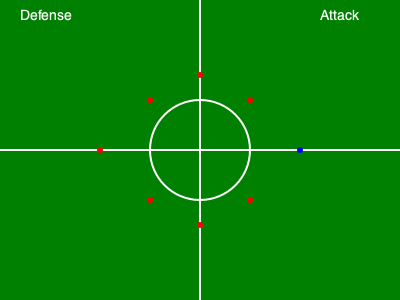Analyze the defensive formation shown in the rugby field schematic. What type of defensive strategy is being employed, and how might it be vulnerable to certain attacking plays? 1. Identification of the formation:
   The defensive formation shown is a "Drift Defense" or "Sliding Defense" strategy.

2. Key characteristics:
   a) The defenders (red dots) are arranged in a curved line, with players spread wider as they move away from the ruck/maul area.
   b) There's a concentration of defenders near the center of the field, with fewer players towards the touchlines.

3. Strengths of this formation:
   a) Effective at covering a wide area of the field.
   b) Allows defenders to move as a unit, maintaining their spacing.
   c) Can quickly adapt to changes in the attacking team's direction.

4. Vulnerabilities:
   a) Inside Breaks: The curved nature of the line can create gaps between defenders, especially closer to the ruck/maul area.
   b) Quick Switches of Play: Rapid changes in the point of attack can catch the defense off-guard as they're sliding in one direction.
   c) Chip Kicks: The fullback (not shown) might be drawn into the line, leaving space behind the defensive line vulnerable to chip kicks.

5. Potential attacking plays to exploit vulnerabilities:
   a) Inside Passes: Quick passes to support runners cutting back against the grain of the defensive slide.
   b) Cross-field Kicks: Exploiting the space left on the far side as the defense slides.
   c) Loop Plays: Creating overlaps by having players loop around the ball carrier, potentially outflanking the drifting defense.

6. Defensive adjustments:
   To counter these vulnerabilities, the defensive team might:
   a) Have inside defenders hold their position longer to prevent inside breaks.
   b) Ensure clear communication to quickly realign if the point of attack changes.
   c) Have the fullback positioned to cover potential chip kicks or cross-field kicks.
Answer: Drift Defense; vulnerable to inside breaks, quick switches of play, and chip kicks. 